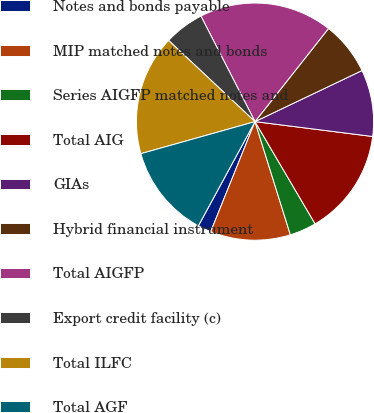<chart> <loc_0><loc_0><loc_500><loc_500><pie_chart><fcel>Notes and bonds payable<fcel>MIP matched notes and bonds<fcel>Series AIGFP matched notes and<fcel>Total AIG<fcel>GIAs<fcel>Hybrid financial instrument<fcel>Total AIGFP<fcel>Export credit facility (c)<fcel>Total ILFC<fcel>Total AGF<nl><fcel>1.83%<fcel>10.91%<fcel>3.64%<fcel>14.54%<fcel>9.09%<fcel>7.28%<fcel>18.17%<fcel>5.46%<fcel>16.36%<fcel>12.72%<nl></chart> 